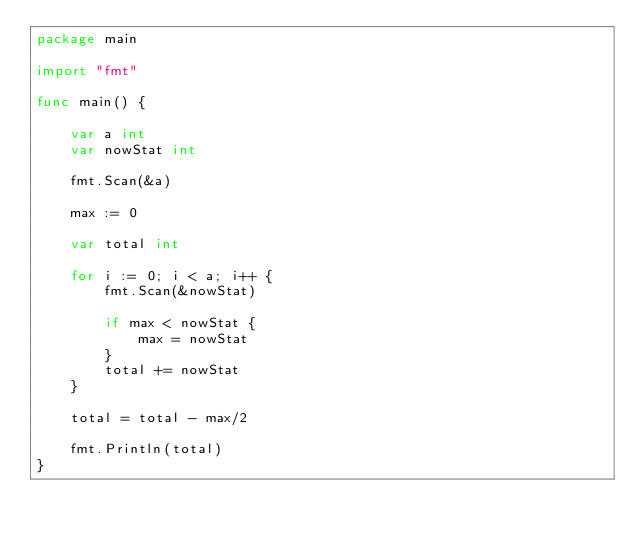Convert code to text. <code><loc_0><loc_0><loc_500><loc_500><_Go_>package main

import "fmt"

func main() {

	var a int
	var nowStat int

	fmt.Scan(&a)

	max := 0

	var total int

	for i := 0; i < a; i++ {
		fmt.Scan(&nowStat)

		if max < nowStat {
			max = nowStat
		}
		total += nowStat
	}

	total = total - max/2

	fmt.Println(total)
}
</code> 